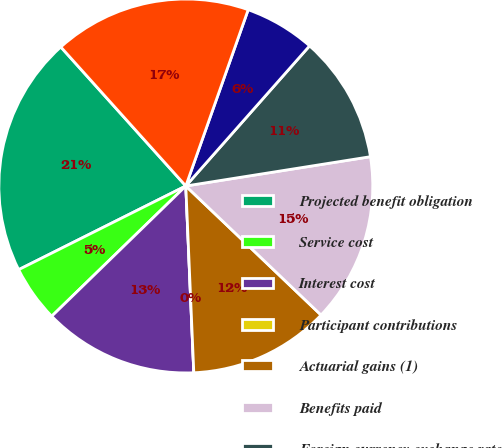<chart> <loc_0><loc_0><loc_500><loc_500><pie_chart><fcel>Projected benefit obligation<fcel>Service cost<fcel>Interest cost<fcel>Participant contributions<fcel>Actuarial gains (1)<fcel>Benefits paid<fcel>Foreign currency exchange rate<fcel>Employer contributions<fcel>Plan assets less than benefit<nl><fcel>20.73%<fcel>4.88%<fcel>13.41%<fcel>0.0%<fcel>12.19%<fcel>14.63%<fcel>10.98%<fcel>6.1%<fcel>17.07%<nl></chart> 